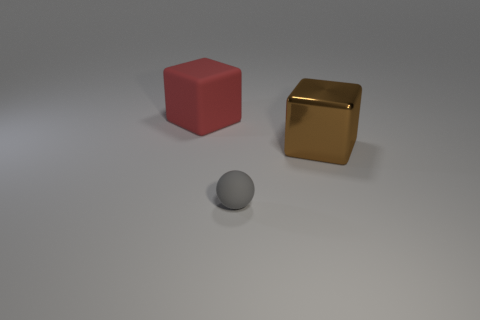What number of cubes are large cyan metallic things or brown things? In the image, there are no cyan objects at all. However, there is one large cube with a metallic finish that is brown in color. So, the total number of cubes that are either large cyan metallic things or brown things is one. 